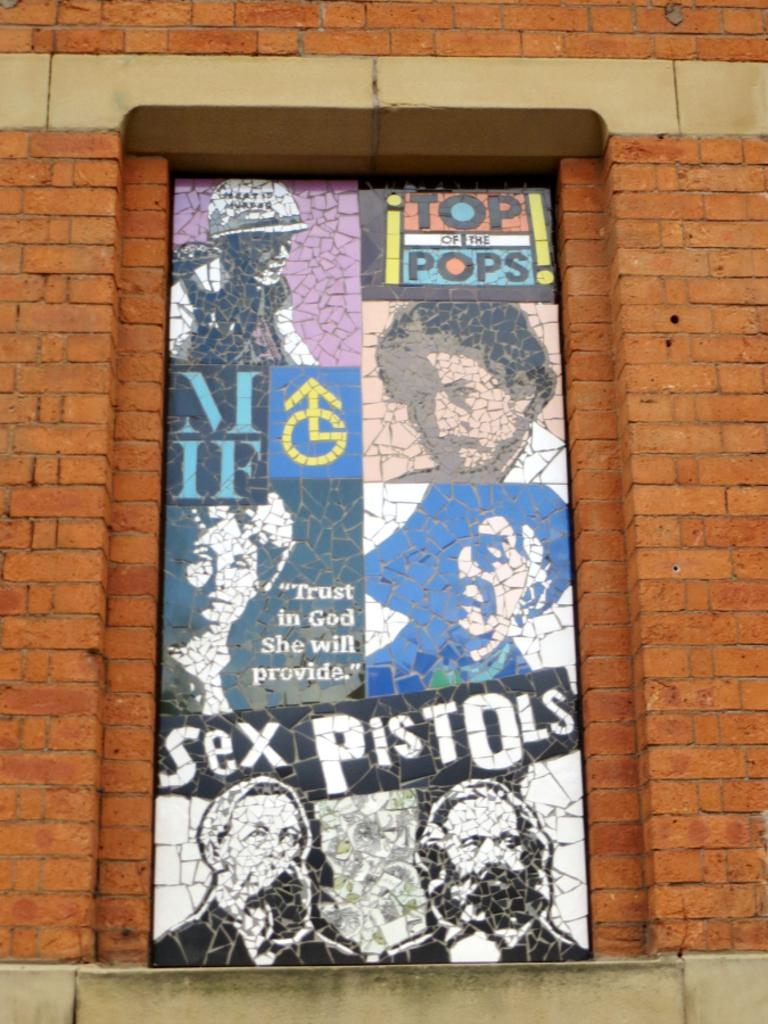<image>
Offer a succinct explanation of the picture presented. the name sex pistols that is on a sign 